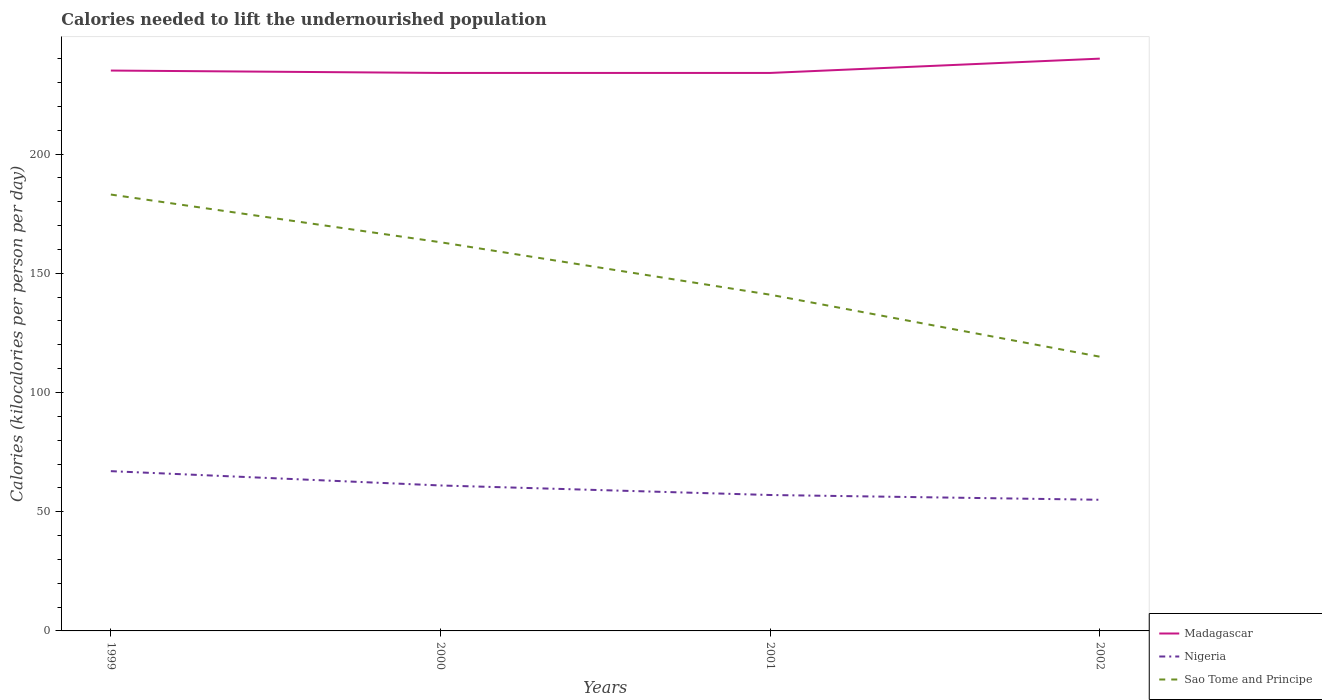Does the line corresponding to Sao Tome and Principe intersect with the line corresponding to Nigeria?
Provide a succinct answer. No. Across all years, what is the maximum total calories needed to lift the undernourished population in Sao Tome and Principe?
Your response must be concise. 115. What is the total total calories needed to lift the undernourished population in Sao Tome and Principe in the graph?
Provide a short and direct response. 48. What is the difference between the highest and the second highest total calories needed to lift the undernourished population in Sao Tome and Principe?
Offer a terse response. 68. What is the difference between the highest and the lowest total calories needed to lift the undernourished population in Sao Tome and Principe?
Your answer should be very brief. 2. How many years are there in the graph?
Give a very brief answer. 4. Does the graph contain grids?
Give a very brief answer. No. Where does the legend appear in the graph?
Give a very brief answer. Bottom right. How are the legend labels stacked?
Provide a short and direct response. Vertical. What is the title of the graph?
Ensure brevity in your answer.  Calories needed to lift the undernourished population. What is the label or title of the Y-axis?
Offer a terse response. Calories (kilocalories per person per day). What is the Calories (kilocalories per person per day) of Madagascar in 1999?
Your response must be concise. 235. What is the Calories (kilocalories per person per day) of Nigeria in 1999?
Provide a short and direct response. 67. What is the Calories (kilocalories per person per day) of Sao Tome and Principe in 1999?
Offer a very short reply. 183. What is the Calories (kilocalories per person per day) of Madagascar in 2000?
Provide a short and direct response. 234. What is the Calories (kilocalories per person per day) of Sao Tome and Principe in 2000?
Provide a succinct answer. 163. What is the Calories (kilocalories per person per day) of Madagascar in 2001?
Offer a terse response. 234. What is the Calories (kilocalories per person per day) of Nigeria in 2001?
Offer a very short reply. 57. What is the Calories (kilocalories per person per day) in Sao Tome and Principe in 2001?
Give a very brief answer. 141. What is the Calories (kilocalories per person per day) of Madagascar in 2002?
Your answer should be very brief. 240. What is the Calories (kilocalories per person per day) of Sao Tome and Principe in 2002?
Your response must be concise. 115. Across all years, what is the maximum Calories (kilocalories per person per day) of Madagascar?
Make the answer very short. 240. Across all years, what is the maximum Calories (kilocalories per person per day) of Nigeria?
Offer a terse response. 67. Across all years, what is the maximum Calories (kilocalories per person per day) of Sao Tome and Principe?
Ensure brevity in your answer.  183. Across all years, what is the minimum Calories (kilocalories per person per day) in Madagascar?
Make the answer very short. 234. Across all years, what is the minimum Calories (kilocalories per person per day) of Sao Tome and Principe?
Give a very brief answer. 115. What is the total Calories (kilocalories per person per day) of Madagascar in the graph?
Provide a short and direct response. 943. What is the total Calories (kilocalories per person per day) in Nigeria in the graph?
Your response must be concise. 240. What is the total Calories (kilocalories per person per day) in Sao Tome and Principe in the graph?
Your response must be concise. 602. What is the difference between the Calories (kilocalories per person per day) in Madagascar in 1999 and that in 2000?
Your answer should be very brief. 1. What is the difference between the Calories (kilocalories per person per day) in Nigeria in 1999 and that in 2001?
Your response must be concise. 10. What is the difference between the Calories (kilocalories per person per day) in Sao Tome and Principe in 1999 and that in 2001?
Your answer should be very brief. 42. What is the difference between the Calories (kilocalories per person per day) of Nigeria in 1999 and that in 2002?
Offer a very short reply. 12. What is the difference between the Calories (kilocalories per person per day) in Sao Tome and Principe in 1999 and that in 2002?
Make the answer very short. 68. What is the difference between the Calories (kilocalories per person per day) of Sao Tome and Principe in 2000 and that in 2002?
Offer a very short reply. 48. What is the difference between the Calories (kilocalories per person per day) in Nigeria in 2001 and that in 2002?
Your response must be concise. 2. What is the difference between the Calories (kilocalories per person per day) in Sao Tome and Principe in 2001 and that in 2002?
Offer a terse response. 26. What is the difference between the Calories (kilocalories per person per day) in Madagascar in 1999 and the Calories (kilocalories per person per day) in Nigeria in 2000?
Your answer should be very brief. 174. What is the difference between the Calories (kilocalories per person per day) of Madagascar in 1999 and the Calories (kilocalories per person per day) of Sao Tome and Principe in 2000?
Your answer should be very brief. 72. What is the difference between the Calories (kilocalories per person per day) in Nigeria in 1999 and the Calories (kilocalories per person per day) in Sao Tome and Principe in 2000?
Offer a terse response. -96. What is the difference between the Calories (kilocalories per person per day) of Madagascar in 1999 and the Calories (kilocalories per person per day) of Nigeria in 2001?
Keep it short and to the point. 178. What is the difference between the Calories (kilocalories per person per day) in Madagascar in 1999 and the Calories (kilocalories per person per day) in Sao Tome and Principe in 2001?
Give a very brief answer. 94. What is the difference between the Calories (kilocalories per person per day) in Nigeria in 1999 and the Calories (kilocalories per person per day) in Sao Tome and Principe in 2001?
Your answer should be compact. -74. What is the difference between the Calories (kilocalories per person per day) of Madagascar in 1999 and the Calories (kilocalories per person per day) of Nigeria in 2002?
Provide a short and direct response. 180. What is the difference between the Calories (kilocalories per person per day) of Madagascar in 1999 and the Calories (kilocalories per person per day) of Sao Tome and Principe in 2002?
Provide a succinct answer. 120. What is the difference between the Calories (kilocalories per person per day) in Nigeria in 1999 and the Calories (kilocalories per person per day) in Sao Tome and Principe in 2002?
Ensure brevity in your answer.  -48. What is the difference between the Calories (kilocalories per person per day) in Madagascar in 2000 and the Calories (kilocalories per person per day) in Nigeria in 2001?
Ensure brevity in your answer.  177. What is the difference between the Calories (kilocalories per person per day) of Madagascar in 2000 and the Calories (kilocalories per person per day) of Sao Tome and Principe in 2001?
Offer a terse response. 93. What is the difference between the Calories (kilocalories per person per day) in Nigeria in 2000 and the Calories (kilocalories per person per day) in Sao Tome and Principe in 2001?
Provide a succinct answer. -80. What is the difference between the Calories (kilocalories per person per day) of Madagascar in 2000 and the Calories (kilocalories per person per day) of Nigeria in 2002?
Your answer should be compact. 179. What is the difference between the Calories (kilocalories per person per day) of Madagascar in 2000 and the Calories (kilocalories per person per day) of Sao Tome and Principe in 2002?
Provide a succinct answer. 119. What is the difference between the Calories (kilocalories per person per day) of Nigeria in 2000 and the Calories (kilocalories per person per day) of Sao Tome and Principe in 2002?
Make the answer very short. -54. What is the difference between the Calories (kilocalories per person per day) of Madagascar in 2001 and the Calories (kilocalories per person per day) of Nigeria in 2002?
Keep it short and to the point. 179. What is the difference between the Calories (kilocalories per person per day) of Madagascar in 2001 and the Calories (kilocalories per person per day) of Sao Tome and Principe in 2002?
Provide a succinct answer. 119. What is the difference between the Calories (kilocalories per person per day) in Nigeria in 2001 and the Calories (kilocalories per person per day) in Sao Tome and Principe in 2002?
Provide a succinct answer. -58. What is the average Calories (kilocalories per person per day) of Madagascar per year?
Keep it short and to the point. 235.75. What is the average Calories (kilocalories per person per day) in Nigeria per year?
Make the answer very short. 60. What is the average Calories (kilocalories per person per day) in Sao Tome and Principe per year?
Provide a short and direct response. 150.5. In the year 1999, what is the difference between the Calories (kilocalories per person per day) in Madagascar and Calories (kilocalories per person per day) in Nigeria?
Make the answer very short. 168. In the year 1999, what is the difference between the Calories (kilocalories per person per day) in Nigeria and Calories (kilocalories per person per day) in Sao Tome and Principe?
Your answer should be very brief. -116. In the year 2000, what is the difference between the Calories (kilocalories per person per day) in Madagascar and Calories (kilocalories per person per day) in Nigeria?
Your response must be concise. 173. In the year 2000, what is the difference between the Calories (kilocalories per person per day) in Madagascar and Calories (kilocalories per person per day) in Sao Tome and Principe?
Provide a short and direct response. 71. In the year 2000, what is the difference between the Calories (kilocalories per person per day) in Nigeria and Calories (kilocalories per person per day) in Sao Tome and Principe?
Keep it short and to the point. -102. In the year 2001, what is the difference between the Calories (kilocalories per person per day) of Madagascar and Calories (kilocalories per person per day) of Nigeria?
Offer a terse response. 177. In the year 2001, what is the difference between the Calories (kilocalories per person per day) of Madagascar and Calories (kilocalories per person per day) of Sao Tome and Principe?
Make the answer very short. 93. In the year 2001, what is the difference between the Calories (kilocalories per person per day) of Nigeria and Calories (kilocalories per person per day) of Sao Tome and Principe?
Keep it short and to the point. -84. In the year 2002, what is the difference between the Calories (kilocalories per person per day) in Madagascar and Calories (kilocalories per person per day) in Nigeria?
Provide a short and direct response. 185. In the year 2002, what is the difference between the Calories (kilocalories per person per day) of Madagascar and Calories (kilocalories per person per day) of Sao Tome and Principe?
Ensure brevity in your answer.  125. In the year 2002, what is the difference between the Calories (kilocalories per person per day) in Nigeria and Calories (kilocalories per person per day) in Sao Tome and Principe?
Provide a short and direct response. -60. What is the ratio of the Calories (kilocalories per person per day) in Madagascar in 1999 to that in 2000?
Your response must be concise. 1. What is the ratio of the Calories (kilocalories per person per day) in Nigeria in 1999 to that in 2000?
Give a very brief answer. 1.1. What is the ratio of the Calories (kilocalories per person per day) in Sao Tome and Principe in 1999 to that in 2000?
Provide a short and direct response. 1.12. What is the ratio of the Calories (kilocalories per person per day) of Madagascar in 1999 to that in 2001?
Provide a short and direct response. 1. What is the ratio of the Calories (kilocalories per person per day) in Nigeria in 1999 to that in 2001?
Provide a succinct answer. 1.18. What is the ratio of the Calories (kilocalories per person per day) in Sao Tome and Principe in 1999 to that in 2001?
Keep it short and to the point. 1.3. What is the ratio of the Calories (kilocalories per person per day) of Madagascar in 1999 to that in 2002?
Your answer should be compact. 0.98. What is the ratio of the Calories (kilocalories per person per day) of Nigeria in 1999 to that in 2002?
Make the answer very short. 1.22. What is the ratio of the Calories (kilocalories per person per day) in Sao Tome and Principe in 1999 to that in 2002?
Provide a short and direct response. 1.59. What is the ratio of the Calories (kilocalories per person per day) in Madagascar in 2000 to that in 2001?
Provide a short and direct response. 1. What is the ratio of the Calories (kilocalories per person per day) in Nigeria in 2000 to that in 2001?
Offer a terse response. 1.07. What is the ratio of the Calories (kilocalories per person per day) of Sao Tome and Principe in 2000 to that in 2001?
Provide a succinct answer. 1.16. What is the ratio of the Calories (kilocalories per person per day) in Madagascar in 2000 to that in 2002?
Offer a terse response. 0.97. What is the ratio of the Calories (kilocalories per person per day) of Nigeria in 2000 to that in 2002?
Make the answer very short. 1.11. What is the ratio of the Calories (kilocalories per person per day) of Sao Tome and Principe in 2000 to that in 2002?
Offer a terse response. 1.42. What is the ratio of the Calories (kilocalories per person per day) in Madagascar in 2001 to that in 2002?
Ensure brevity in your answer.  0.97. What is the ratio of the Calories (kilocalories per person per day) in Nigeria in 2001 to that in 2002?
Your response must be concise. 1.04. What is the ratio of the Calories (kilocalories per person per day) of Sao Tome and Principe in 2001 to that in 2002?
Your response must be concise. 1.23. What is the difference between the highest and the second highest Calories (kilocalories per person per day) in Madagascar?
Keep it short and to the point. 5. What is the difference between the highest and the second highest Calories (kilocalories per person per day) of Sao Tome and Principe?
Ensure brevity in your answer.  20. What is the difference between the highest and the lowest Calories (kilocalories per person per day) of Madagascar?
Keep it short and to the point. 6. What is the difference between the highest and the lowest Calories (kilocalories per person per day) in Nigeria?
Your response must be concise. 12. What is the difference between the highest and the lowest Calories (kilocalories per person per day) of Sao Tome and Principe?
Ensure brevity in your answer.  68. 